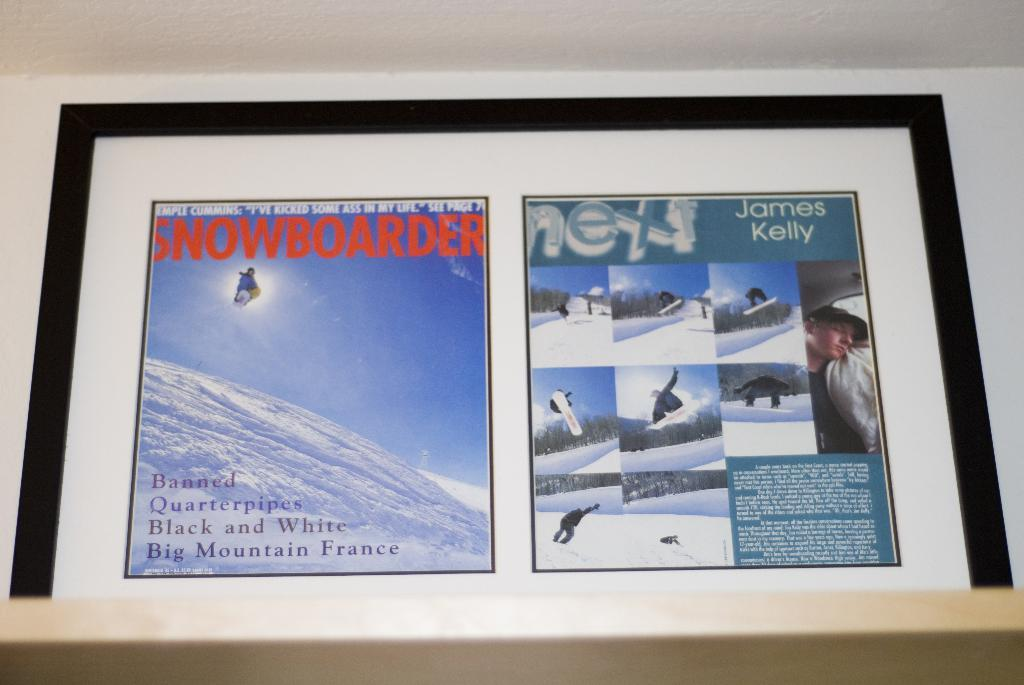Provide a one-sentence caption for the provided image. A picture frame that has a Snowboarder article as well as pictures of snowboarders. 